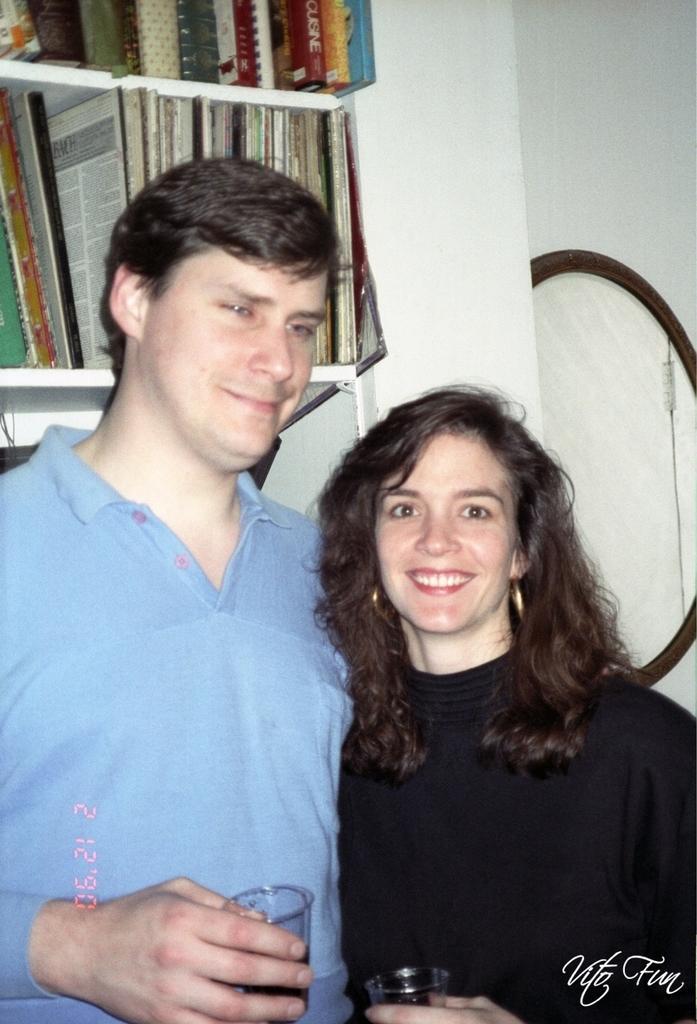Can you describe this image briefly? In this image there is a couple who are holding the glasses. In the background there are racks in which there are books. On the right side there is a mirror. 